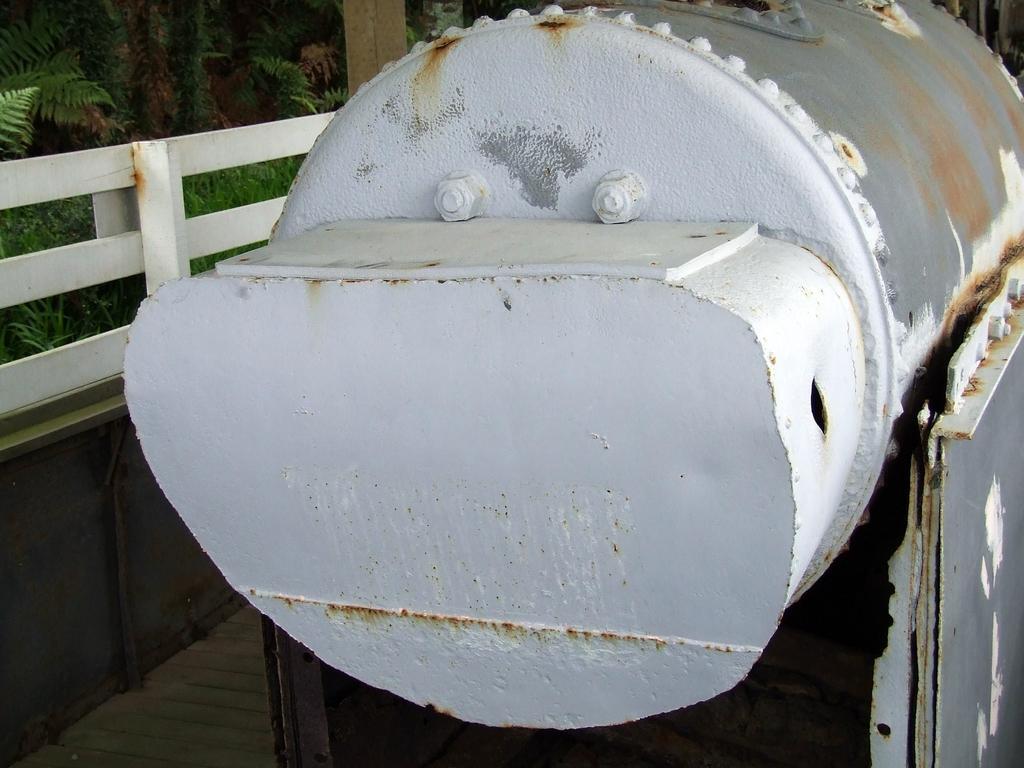Describe this image in one or two sentences. There is a white cylindrical metal object. It has nuts and bolts. There is a white fence at the left and there are trees behind it. 